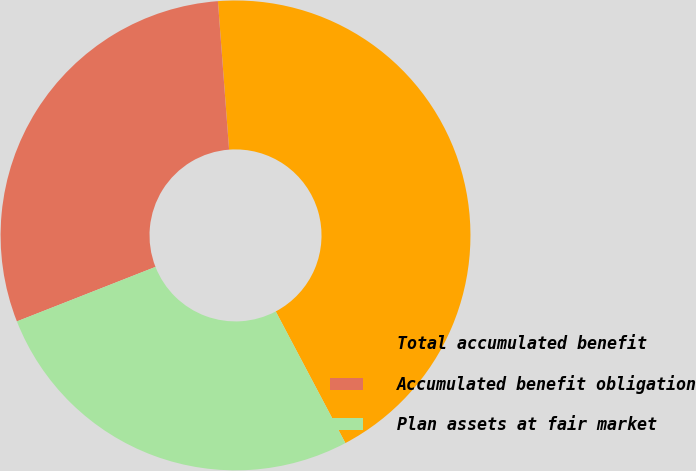Convert chart. <chart><loc_0><loc_0><loc_500><loc_500><pie_chart><fcel>Total accumulated benefit<fcel>Accumulated benefit obligation<fcel>Plan assets at fair market<nl><fcel>43.45%<fcel>29.77%<fcel>26.78%<nl></chart> 